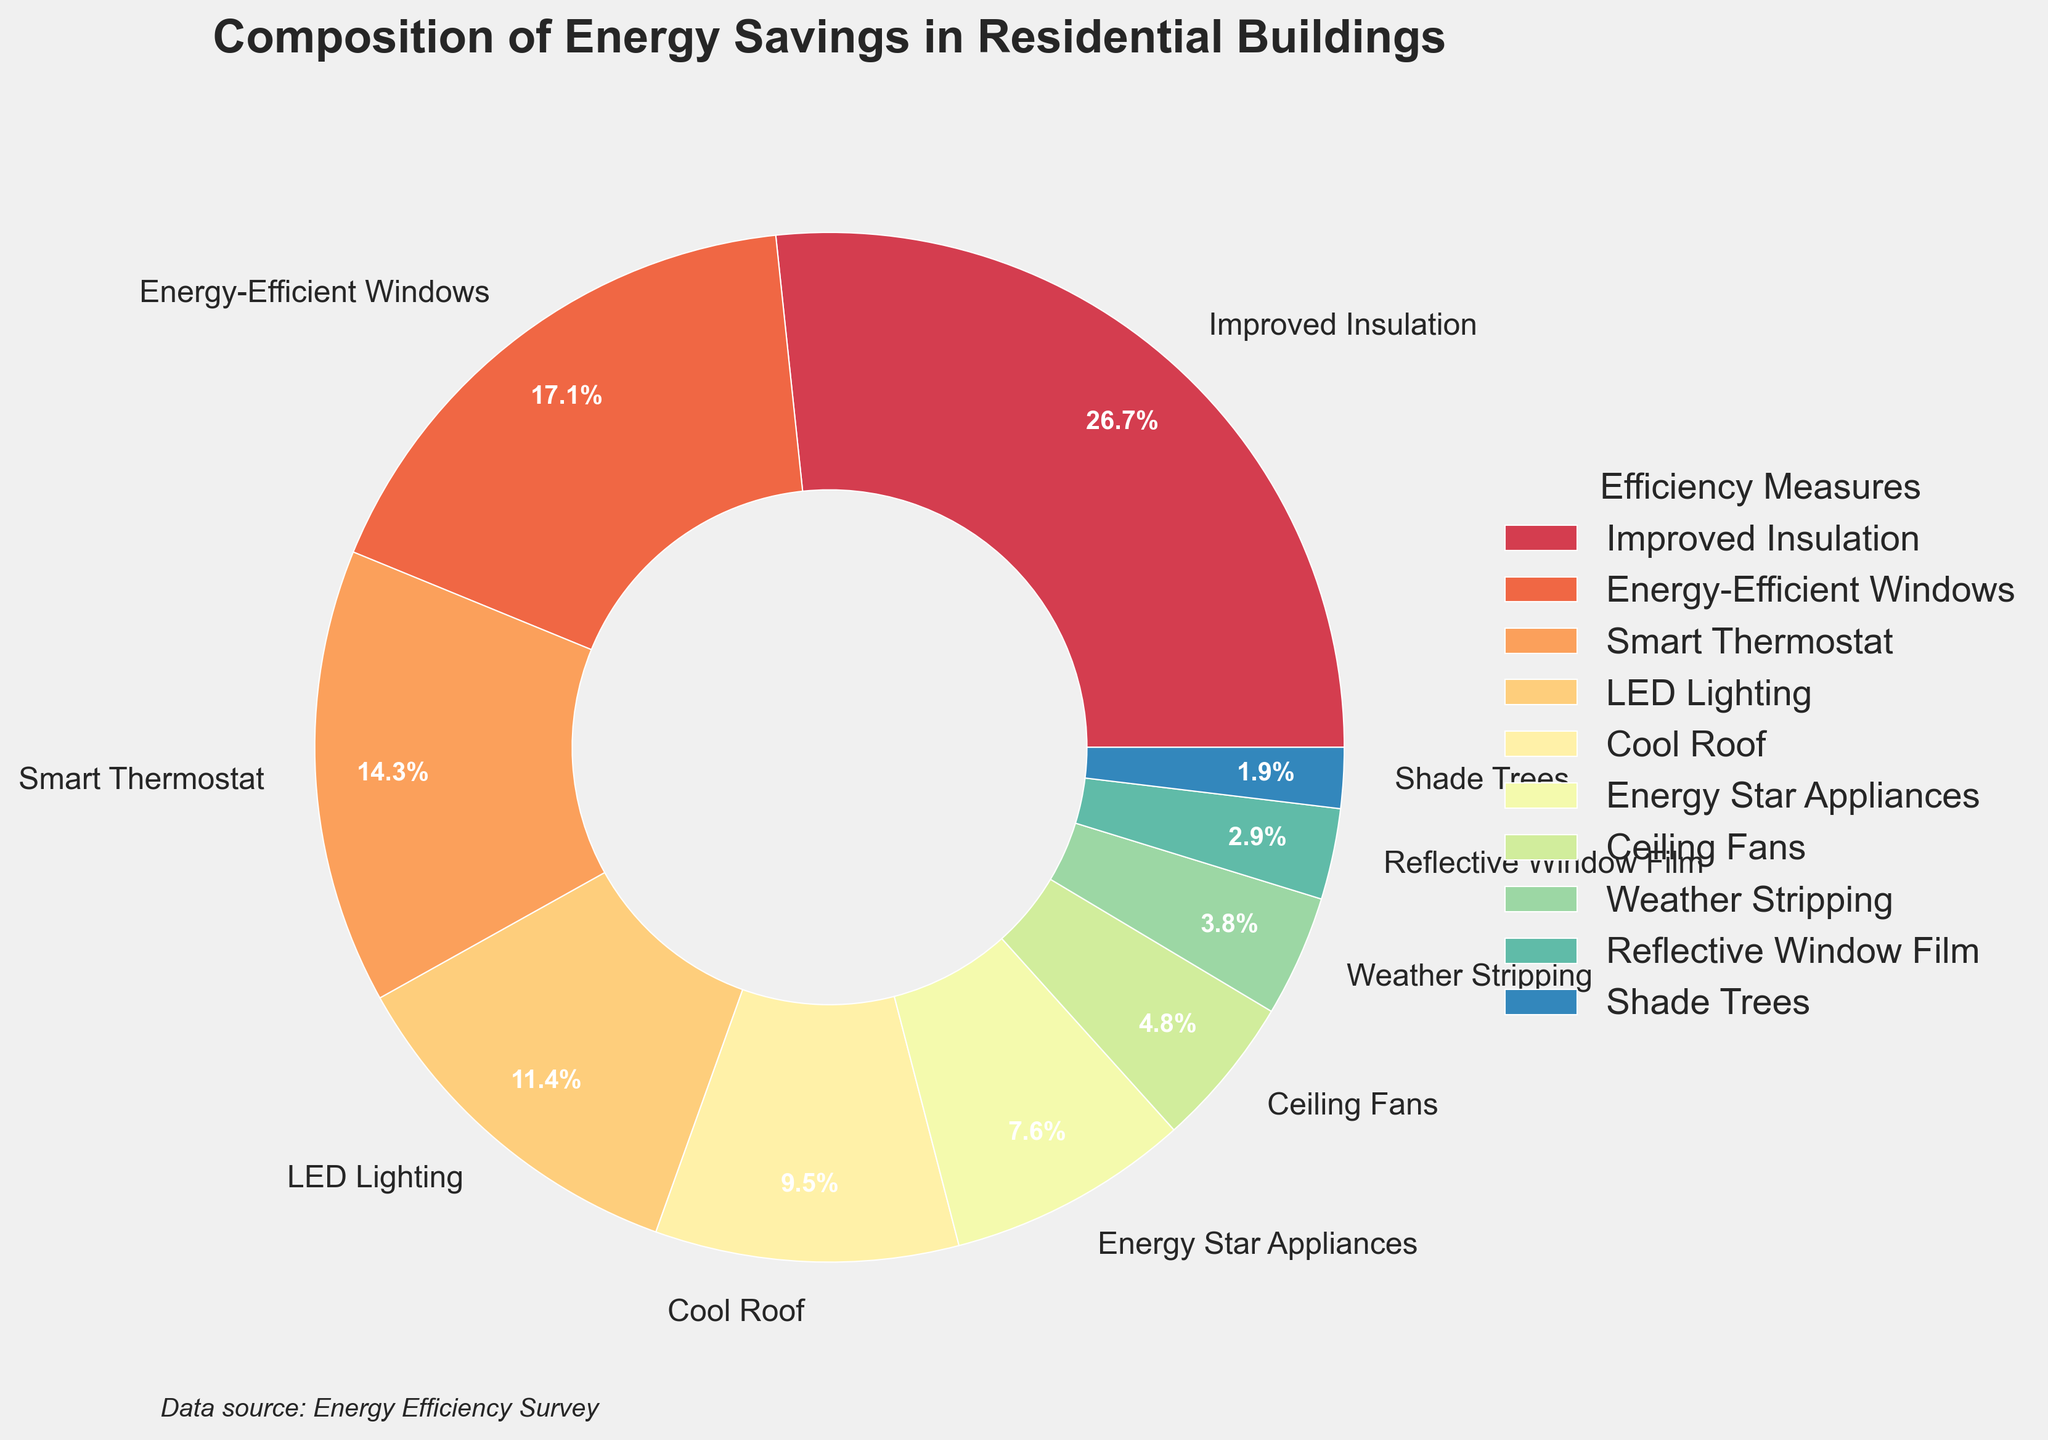What percentage of energy savings come from energy-efficient windows compared to LED lighting? Energy-efficient windows contribute 18%, and LED lighting contributes 12%. Therefore, energy-efficient windows save 6% more than LED lighting.
Answer: 6% Which measure contributes less to energy savings: smart thermostat or cool roof? Smart thermostat contributes 15%, and cool roof contributes 10%. Since 15% is more than 10%, cool roof contributes less.
Answer: Cool roof How much combined energy savings are achieved from improved insulation and energy-efficient windows? Improved insulation contributes 28%, and energy-efficient windows contribute 18%. Adding these, the combined savings are 28% + 18% = 46%.
Answer: 46% Which energy-saving measure has the smallest contribution, and what is its value? Shade trees have the smallest contribution, with a value of 2%.
Answer: Shade trees, 2% Do ceiling fans save more energy than weather stripping? Ceiling fans contribute 5%, while weather stripping contributes 4%. Since 5% is more than 4%, ceiling fans save more energy than weather stripping.
Answer: Yes What is the total percentage contribution of measures that save under 10% each? The measures under 10% are Cool Roof (10%), Energy Star Appliances (8%), Ceiling Fans (5%), Weather Stripping (4%), Reflective Window Film (3%), and Shade Trees (2%). Summing these, the total is 10% + 8% + 5% + 4% + 3% + 2% = 32%.
Answer: 32% If you combine the savings from LED lighting, Energy Star appliances, and ceiling fans, does it surpass the savings from improved insulation alone? LED lighting contributes 12%, Energy Star appliances contribute 8%, and ceiling fans contribute 5%. Combining these, the total is 12% + 8% + 5% = 25%. Improved insulation alone contributes 28%. Since 25% is less than 28%, the combined savings do not surpass improved insulation.
Answer: No What is the average percentage of energy savings for all the measures? Adding all the percentages, we get: 28% + 18% + 15% + 12% + 10% + 8% + 5% + 4% + 3% + 2% = 105%. There are 10 measures. The average percentage is 105% / 10 measures = 10.5%.
Answer: 10.5% How much more energy savings do improved insulation and smart thermostat together achieve compared to the combined savings of reflective window film, shade trees, and weather stripping? Improved insulation and smart thermostat together contribute 28% + 15% = 43%. Reflective window film, shade trees, and weather stripping together contribute 3% + 2% + 4% = 9%. The difference is 43% - 9% = 34%.
Answer: 34% 